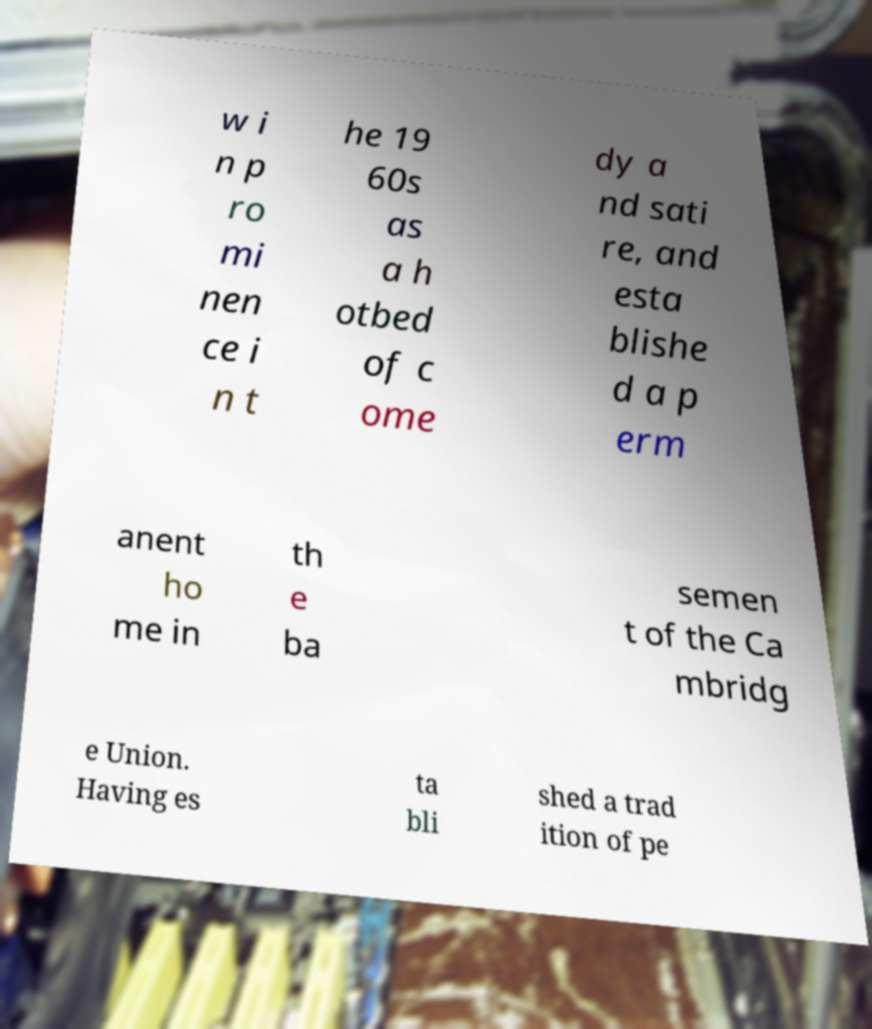Can you accurately transcribe the text from the provided image for me? w i n p ro mi nen ce i n t he 19 60s as a h otbed of c ome dy a nd sati re, and esta blishe d a p erm anent ho me in th e ba semen t of the Ca mbridg e Union. Having es ta bli shed a trad ition of pe 